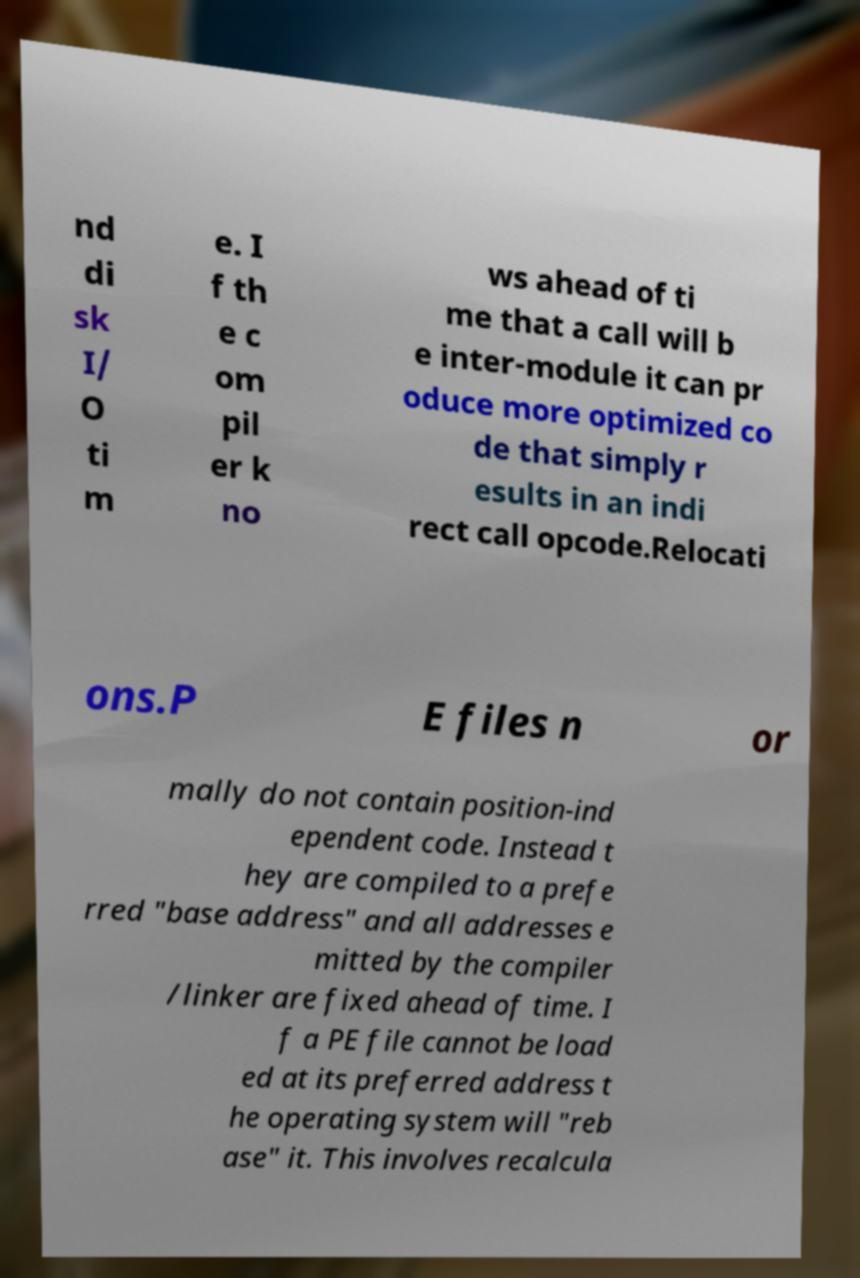Could you assist in decoding the text presented in this image and type it out clearly? nd di sk I/ O ti m e. I f th e c om pil er k no ws ahead of ti me that a call will b e inter-module it can pr oduce more optimized co de that simply r esults in an indi rect call opcode.Relocati ons.P E files n or mally do not contain position-ind ependent code. Instead t hey are compiled to a prefe rred "base address" and all addresses e mitted by the compiler /linker are fixed ahead of time. I f a PE file cannot be load ed at its preferred address t he operating system will "reb ase" it. This involves recalcula 